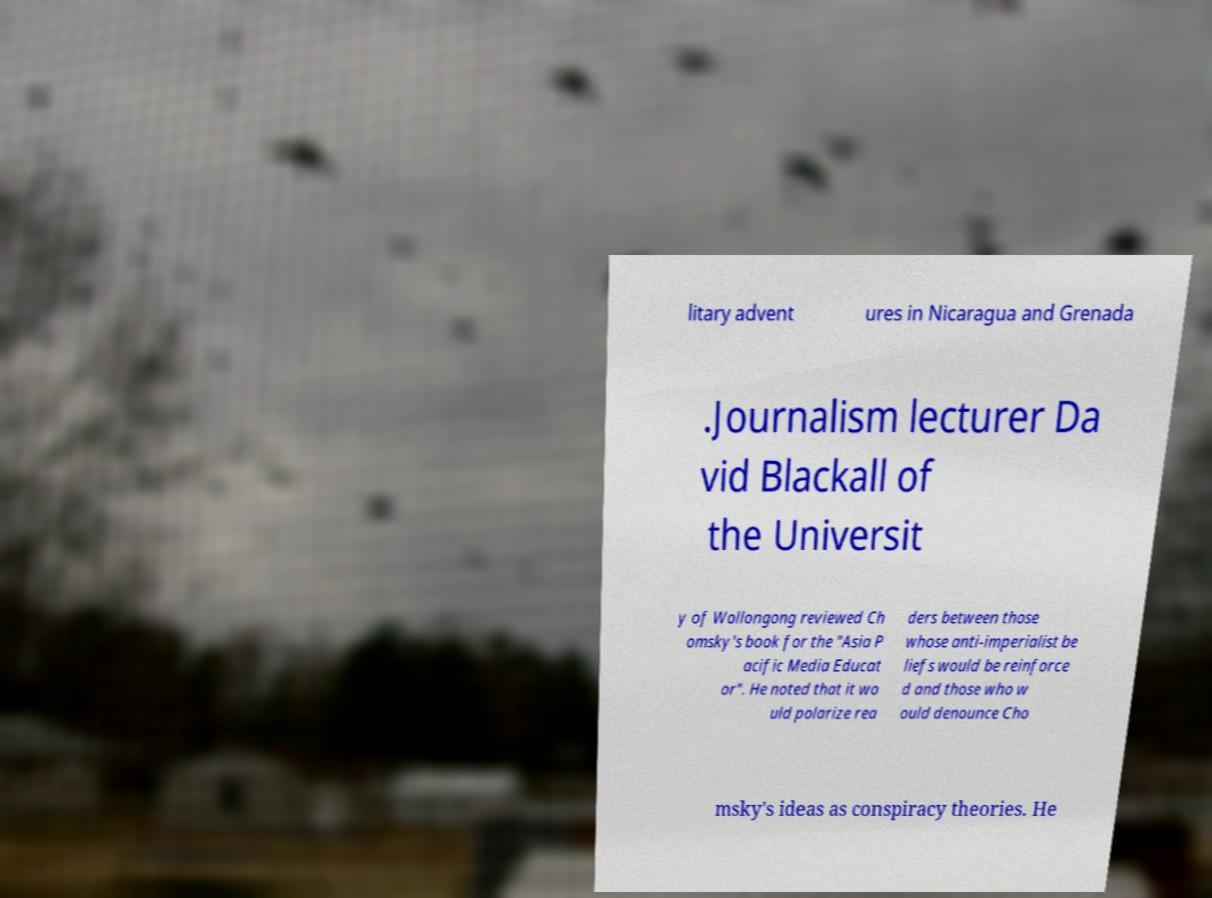Please read and relay the text visible in this image. What does it say? litary advent ures in Nicaragua and Grenada .Journalism lecturer Da vid Blackall of the Universit y of Wollongong reviewed Ch omsky's book for the "Asia P acific Media Educat or". He noted that it wo uld polarize rea ders between those whose anti-imperialist be liefs would be reinforce d and those who w ould denounce Cho msky's ideas as conspiracy theories. He 